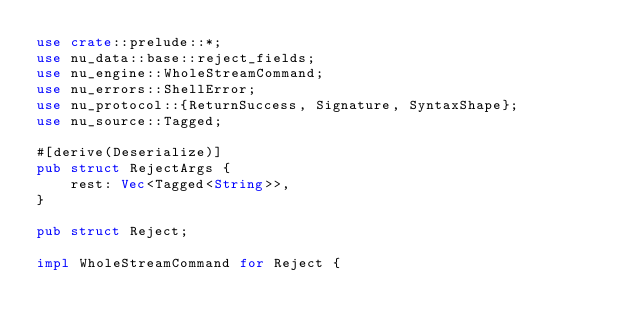<code> <loc_0><loc_0><loc_500><loc_500><_Rust_>use crate::prelude::*;
use nu_data::base::reject_fields;
use nu_engine::WholeStreamCommand;
use nu_errors::ShellError;
use nu_protocol::{ReturnSuccess, Signature, SyntaxShape};
use nu_source::Tagged;

#[derive(Deserialize)]
pub struct RejectArgs {
    rest: Vec<Tagged<String>>,
}

pub struct Reject;

impl WholeStreamCommand for Reject {</code> 